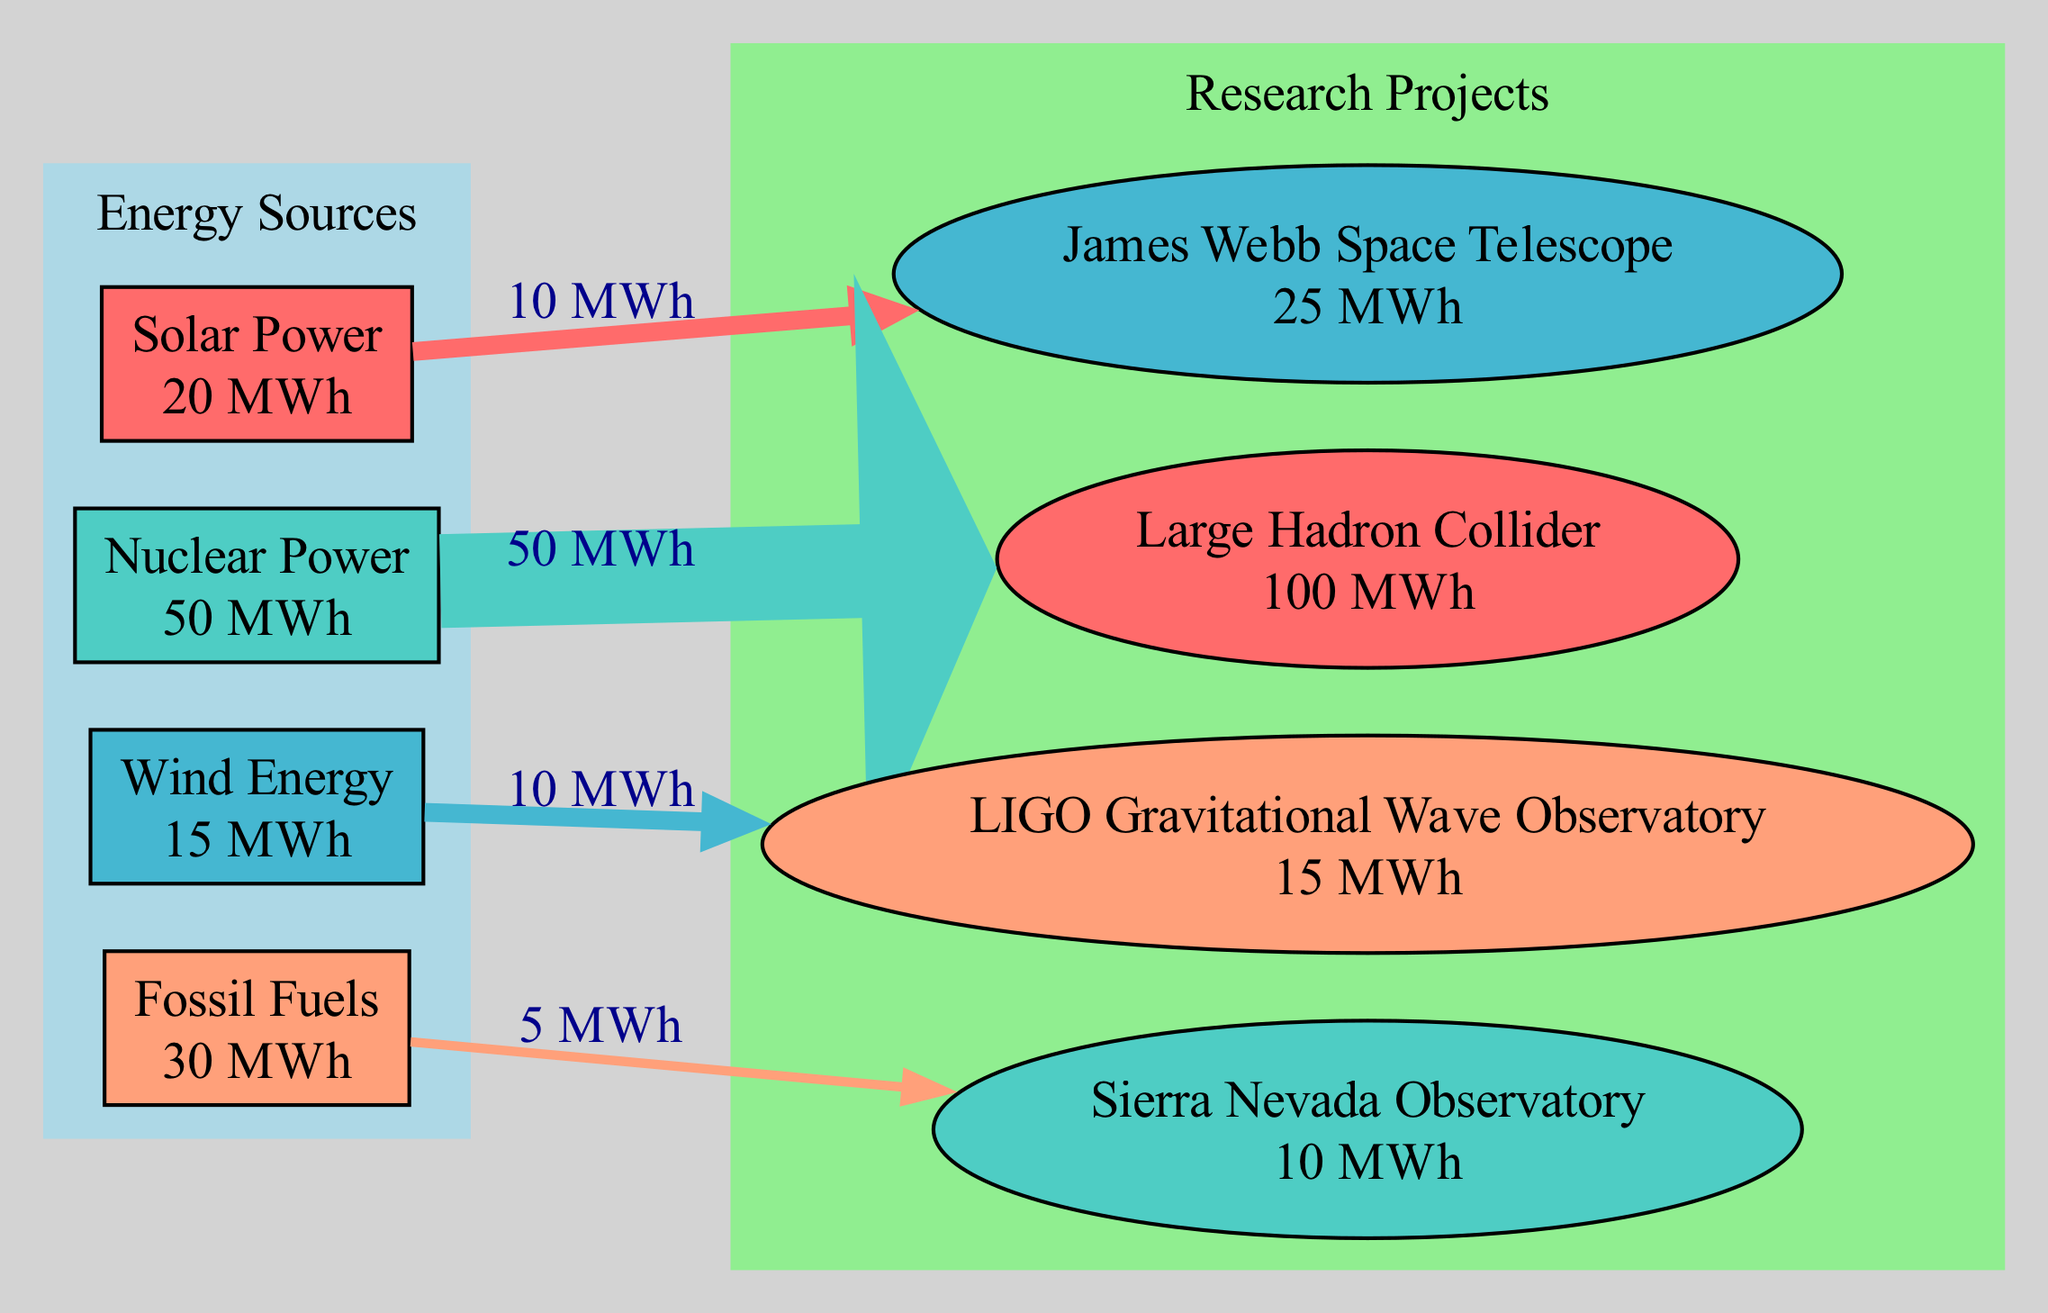What is the total energy consumption of the Large Hadron Collider? The diagram shows that the energy consumption for the Large Hadron Collider is labeled as 100 MWh.
Answer: 100 MWh Which research project uses solar power? Looking at the energy distribution in the diagram, the arrow from "Solar Power" leads to "James Webb Space Telescope," indicating that it uses solar power.
Answer: James Webb Space Telescope How much energy does the Sierra Nevada Observatory consume? Referring to the labels in the diagram, it specifies that the Sierra Nevada Observatory's energy consumption is stated as 10 MWh.
Answer: 10 MWh What is the total amount of energy from wind energy used by the projects? According to the diagram, the only project that uses wind energy is the LIGO Gravitational Wave Observatory, which indicates that 10 MWh comes from there.
Answer: 10 MWh Which energy source contributes the most to research projects? The diagram shows that the "Nuclear Power" energy source is connected to the "Large Hadron Collider" with an amount of 50 MWh, which is the highest among the contributions, making it the most significant source.
Answer: Nuclear Power How many edges are displayed in this diagram? By counting the connections visible in the Sankey Diagram, there are a total of four directed edges representing the flow of energy from sources to projects.
Answer: 4 What amount of fossil fuel energy is consumed by the Sierra Nevada Observatory? The diagram clearly shows an arrow from "Fossil Fuels" to "Sierra Nevada Observatory" with the label indicating it uses 5 MWh of energy from fossil fuels.
Answer: 5 MWh Which energy source has the least contribution in this diagram? Looking at the energy sources, "Wind Energy" at 15 MWh is the smallest amount being supplied to a project (10 MWh to LIGO), making it the least contributing source overall.
Answer: Wind Energy 